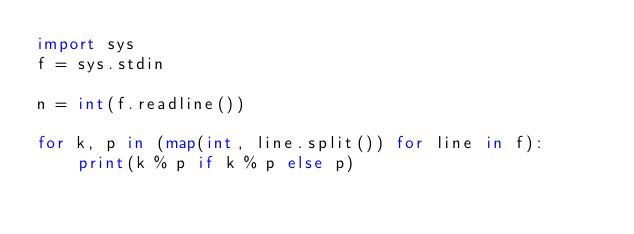Convert code to text. <code><loc_0><loc_0><loc_500><loc_500><_Python_>import sys
f = sys.stdin

n = int(f.readline())

for k, p in (map(int, line.split()) for line in f):
    print(k % p if k % p else p)</code> 